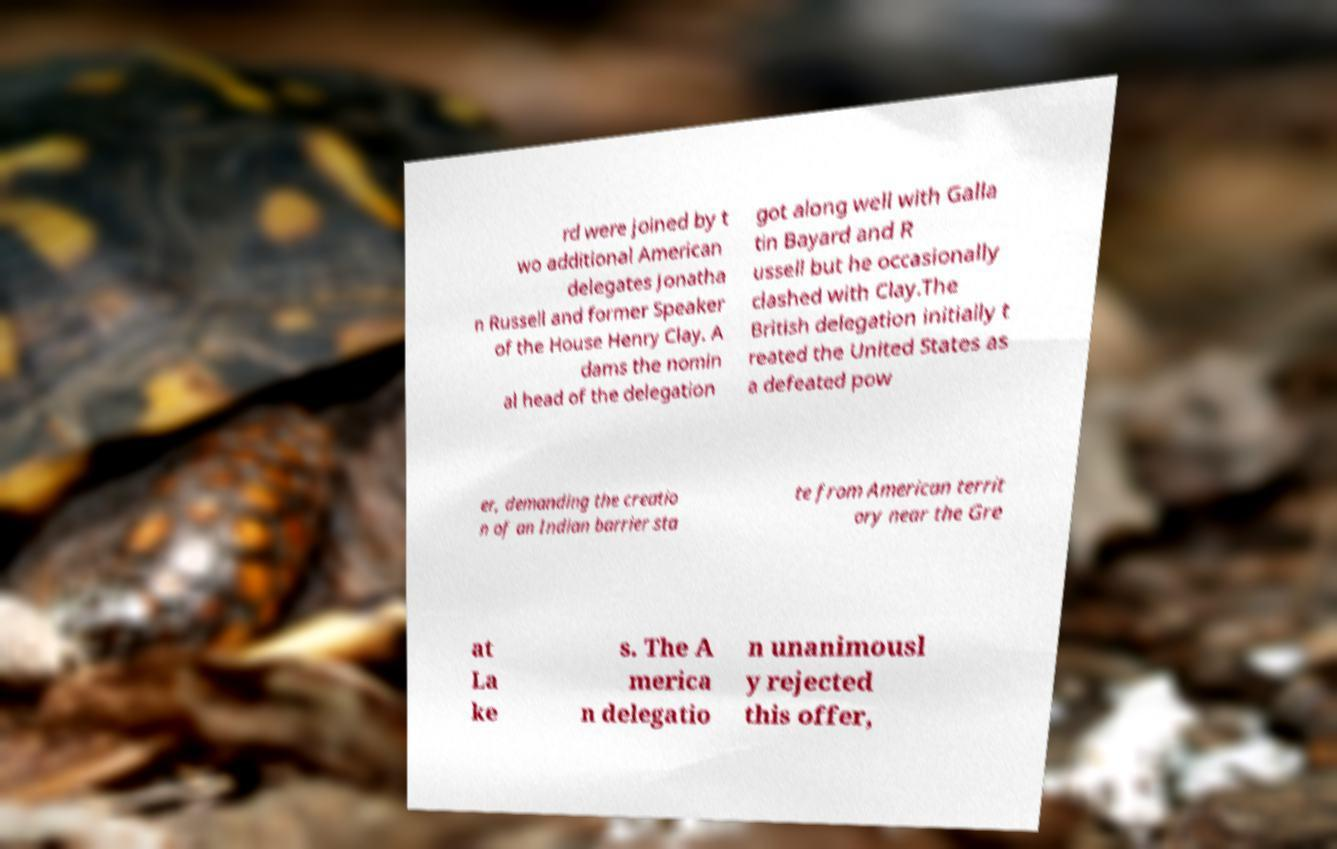What messages or text are displayed in this image? I need them in a readable, typed format. rd were joined by t wo additional American delegates Jonatha n Russell and former Speaker of the House Henry Clay. A dams the nomin al head of the delegation got along well with Galla tin Bayard and R ussell but he occasionally clashed with Clay.The British delegation initially t reated the United States as a defeated pow er, demanding the creatio n of an Indian barrier sta te from American territ ory near the Gre at La ke s. The A merica n delegatio n unanimousl y rejected this offer, 